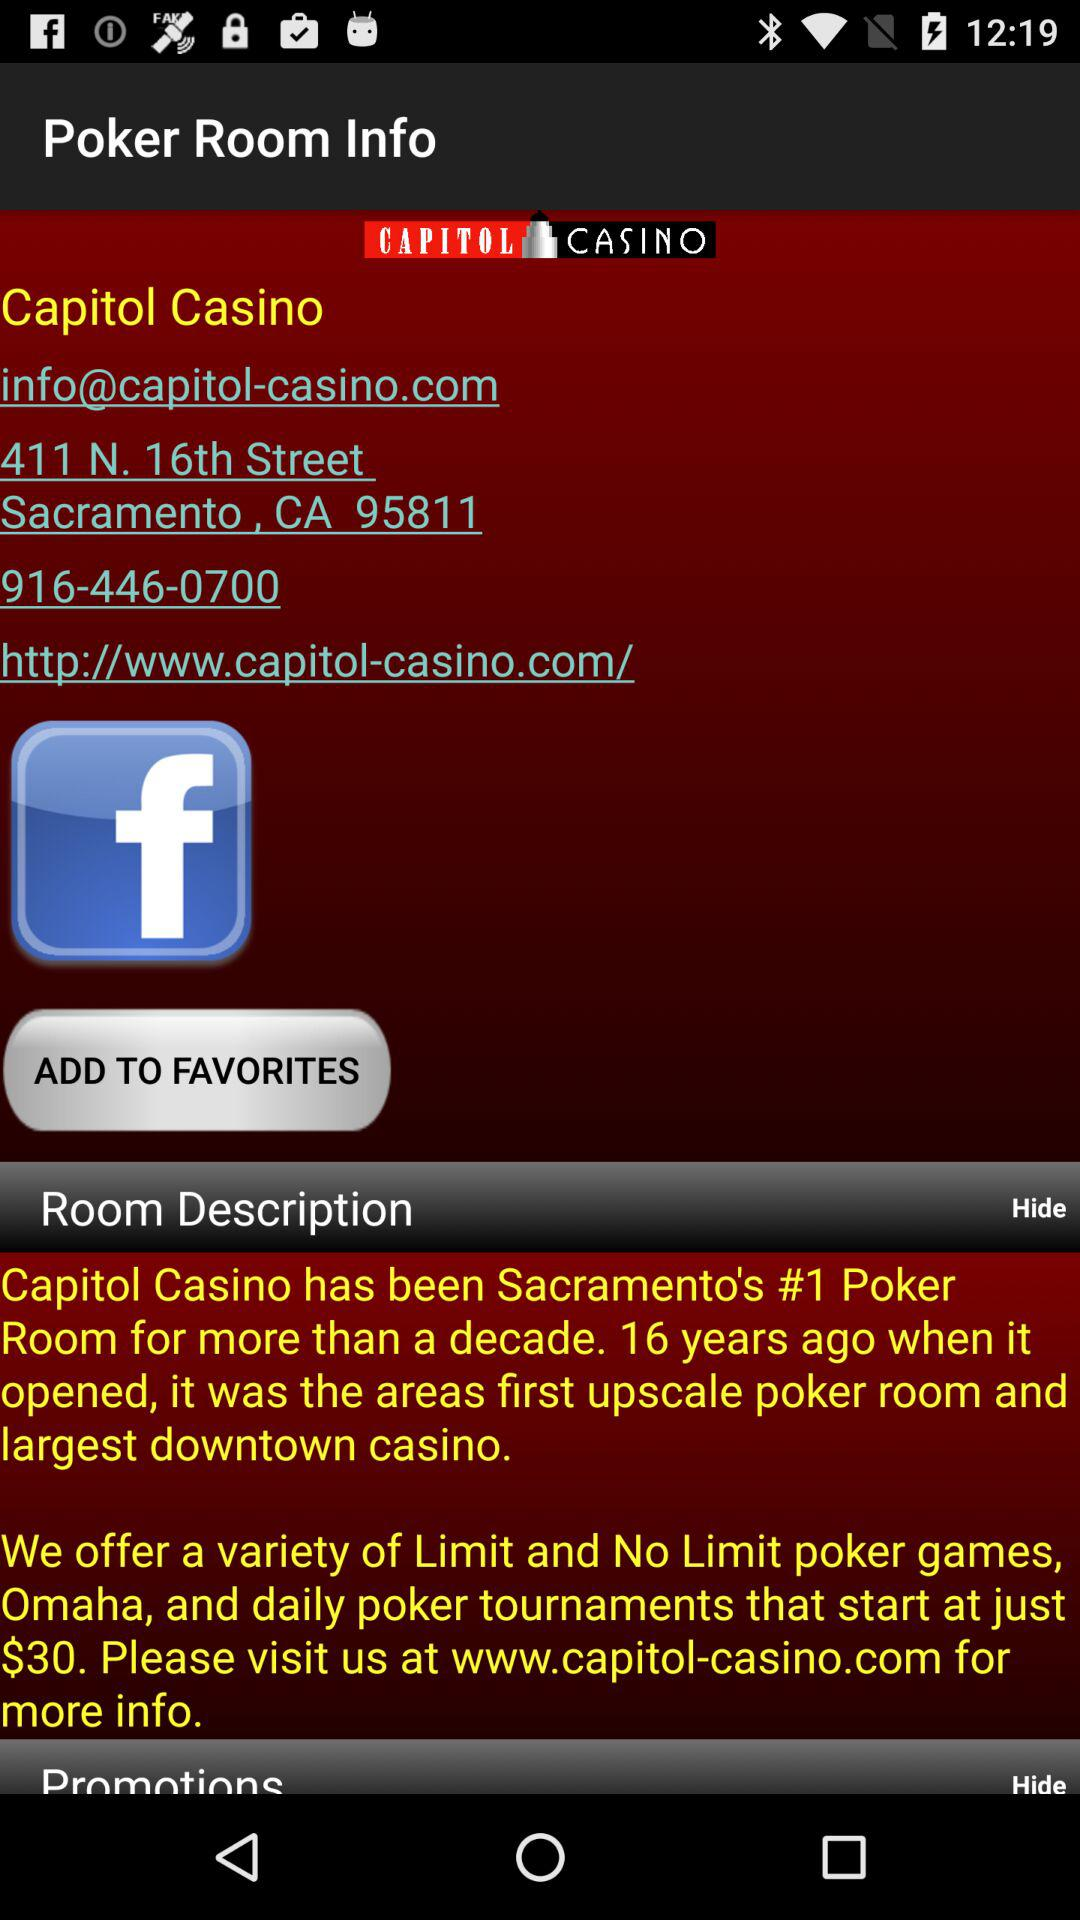What is the email address? The email address is info@capitol-casino.com. 